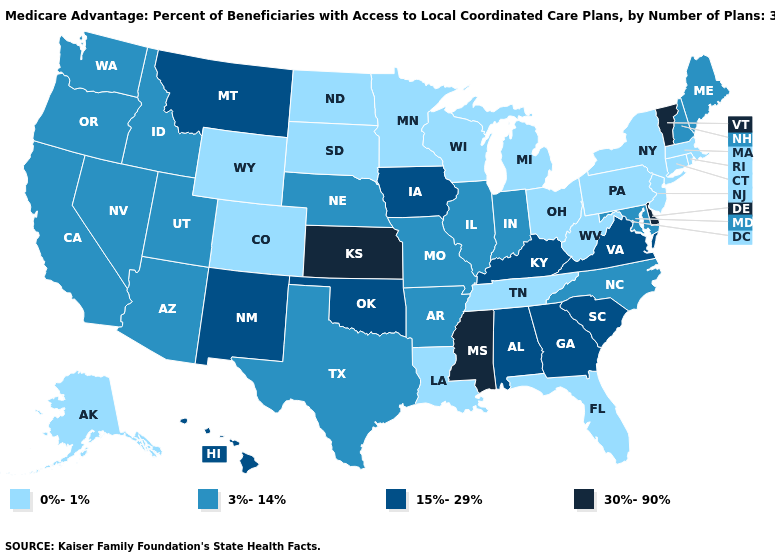Name the states that have a value in the range 0%-1%?
Answer briefly. Colorado, Connecticut, Florida, Louisiana, Massachusetts, Michigan, Minnesota, North Dakota, New Jersey, New York, Ohio, Pennsylvania, Rhode Island, South Dakota, Alaska, Tennessee, Wisconsin, West Virginia, Wyoming. Does the first symbol in the legend represent the smallest category?
Answer briefly. Yes. Among the states that border Idaho , which have the lowest value?
Quick response, please. Wyoming. Name the states that have a value in the range 3%-14%?
Be succinct. California, Idaho, Illinois, Indiana, Maryland, Maine, Missouri, North Carolina, Nebraska, New Hampshire, Nevada, Oregon, Texas, Utah, Washington, Arkansas, Arizona. Does Hawaii have the highest value in the West?
Keep it brief. Yes. Name the states that have a value in the range 3%-14%?
Be succinct. California, Idaho, Illinois, Indiana, Maryland, Maine, Missouri, North Carolina, Nebraska, New Hampshire, Nevada, Oregon, Texas, Utah, Washington, Arkansas, Arizona. Does Ohio have the lowest value in the USA?
Concise answer only. Yes. Name the states that have a value in the range 15%-29%?
Answer briefly. Georgia, Hawaii, Iowa, Kentucky, Montana, New Mexico, Oklahoma, South Carolina, Virginia, Alabama. Does Nevada have the lowest value in the USA?
Write a very short answer. No. What is the highest value in states that border Arizona?
Concise answer only. 15%-29%. What is the highest value in the MidWest ?
Answer briefly. 30%-90%. What is the value of North Dakota?
Give a very brief answer. 0%-1%. Does Massachusetts have the highest value in the Northeast?
Give a very brief answer. No. Does Kansas have the highest value in the USA?
Write a very short answer. Yes. Name the states that have a value in the range 0%-1%?
Write a very short answer. Colorado, Connecticut, Florida, Louisiana, Massachusetts, Michigan, Minnesota, North Dakota, New Jersey, New York, Ohio, Pennsylvania, Rhode Island, South Dakota, Alaska, Tennessee, Wisconsin, West Virginia, Wyoming. 